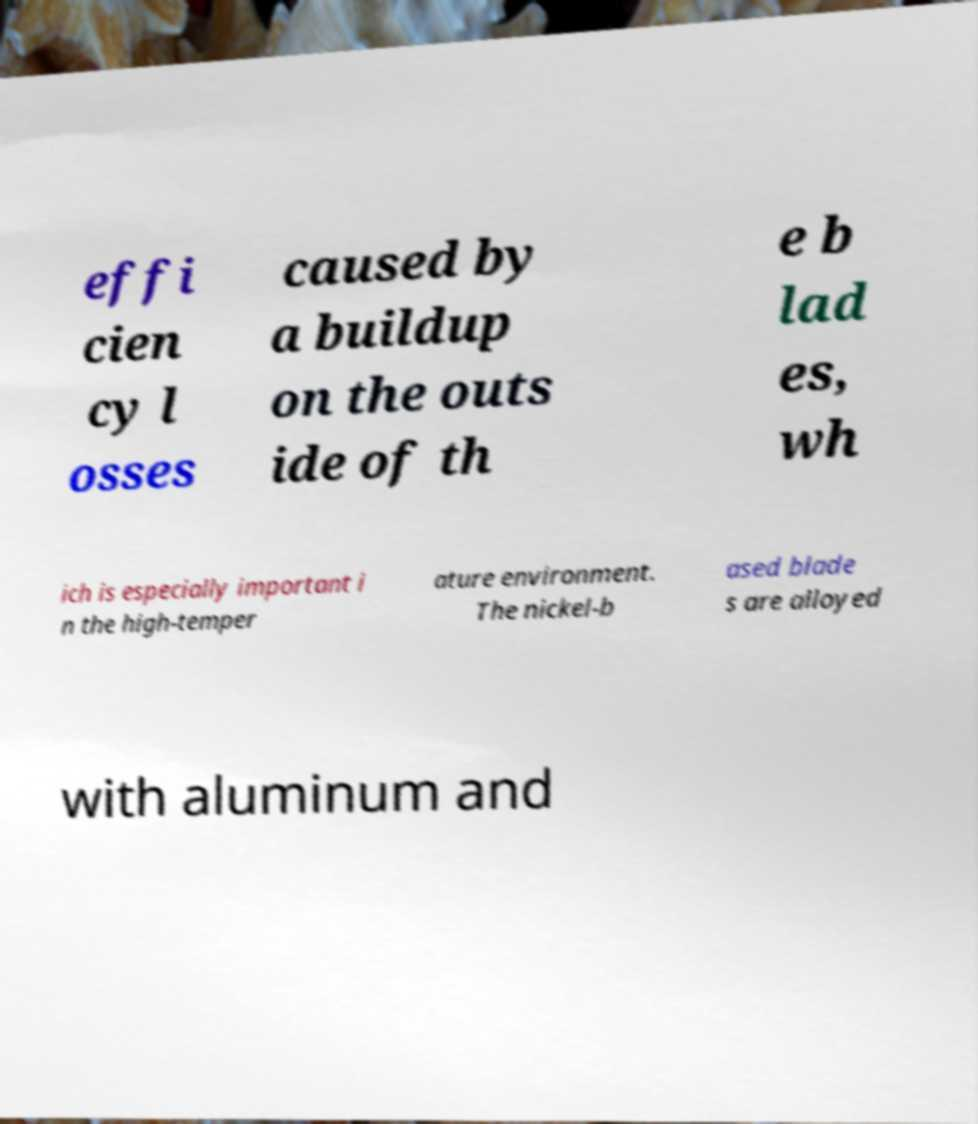Can you read and provide the text displayed in the image?This photo seems to have some interesting text. Can you extract and type it out for me? effi cien cy l osses caused by a buildup on the outs ide of th e b lad es, wh ich is especially important i n the high-temper ature environment. The nickel-b ased blade s are alloyed with aluminum and 